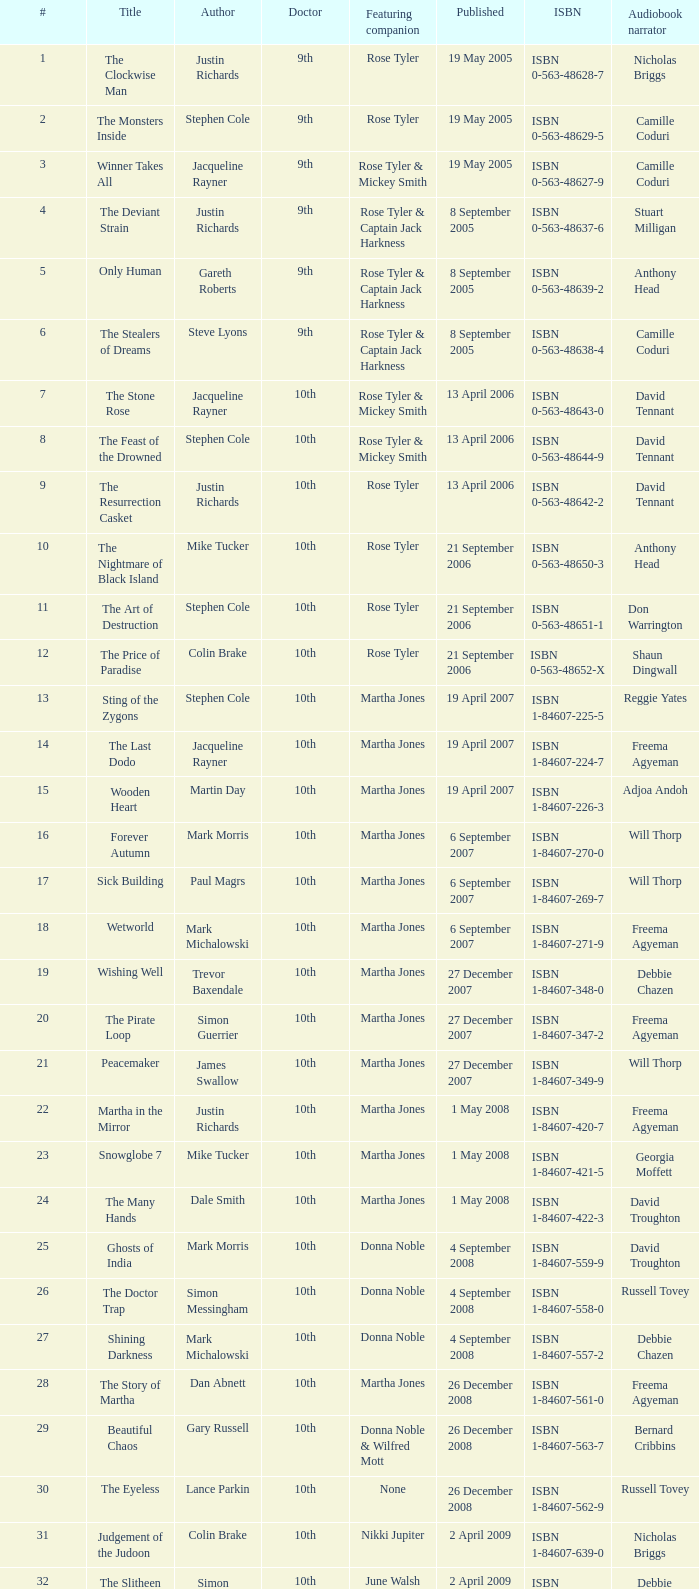What is the designation of book number 7? The Stone Rose. I'm looking to parse the entire table for insights. Could you assist me with that? {'header': ['#', 'Title', 'Author', 'Doctor', 'Featuring companion', 'Published', 'ISBN', 'Audiobook narrator'], 'rows': [['1', 'The Clockwise Man', 'Justin Richards', '9th', 'Rose Tyler', '19 May 2005', 'ISBN 0-563-48628-7', 'Nicholas Briggs'], ['2', 'The Monsters Inside', 'Stephen Cole', '9th', 'Rose Tyler', '19 May 2005', 'ISBN 0-563-48629-5', 'Camille Coduri'], ['3', 'Winner Takes All', 'Jacqueline Rayner', '9th', 'Rose Tyler & Mickey Smith', '19 May 2005', 'ISBN 0-563-48627-9', 'Camille Coduri'], ['4', 'The Deviant Strain', 'Justin Richards', '9th', 'Rose Tyler & Captain Jack Harkness', '8 September 2005', 'ISBN 0-563-48637-6', 'Stuart Milligan'], ['5', 'Only Human', 'Gareth Roberts', '9th', 'Rose Tyler & Captain Jack Harkness', '8 September 2005', 'ISBN 0-563-48639-2', 'Anthony Head'], ['6', 'The Stealers of Dreams', 'Steve Lyons', '9th', 'Rose Tyler & Captain Jack Harkness', '8 September 2005', 'ISBN 0-563-48638-4', 'Camille Coduri'], ['7', 'The Stone Rose', 'Jacqueline Rayner', '10th', 'Rose Tyler & Mickey Smith', '13 April 2006', 'ISBN 0-563-48643-0', 'David Tennant'], ['8', 'The Feast of the Drowned', 'Stephen Cole', '10th', 'Rose Tyler & Mickey Smith', '13 April 2006', 'ISBN 0-563-48644-9', 'David Tennant'], ['9', 'The Resurrection Casket', 'Justin Richards', '10th', 'Rose Tyler', '13 April 2006', 'ISBN 0-563-48642-2', 'David Tennant'], ['10', 'The Nightmare of Black Island', 'Mike Tucker', '10th', 'Rose Tyler', '21 September 2006', 'ISBN 0-563-48650-3', 'Anthony Head'], ['11', 'The Art of Destruction', 'Stephen Cole', '10th', 'Rose Tyler', '21 September 2006', 'ISBN 0-563-48651-1', 'Don Warrington'], ['12', 'The Price of Paradise', 'Colin Brake', '10th', 'Rose Tyler', '21 September 2006', 'ISBN 0-563-48652-X', 'Shaun Dingwall'], ['13', 'Sting of the Zygons', 'Stephen Cole', '10th', 'Martha Jones', '19 April 2007', 'ISBN 1-84607-225-5', 'Reggie Yates'], ['14', 'The Last Dodo', 'Jacqueline Rayner', '10th', 'Martha Jones', '19 April 2007', 'ISBN 1-84607-224-7', 'Freema Agyeman'], ['15', 'Wooden Heart', 'Martin Day', '10th', 'Martha Jones', '19 April 2007', 'ISBN 1-84607-226-3', 'Adjoa Andoh'], ['16', 'Forever Autumn', 'Mark Morris', '10th', 'Martha Jones', '6 September 2007', 'ISBN 1-84607-270-0', 'Will Thorp'], ['17', 'Sick Building', 'Paul Magrs', '10th', 'Martha Jones', '6 September 2007', 'ISBN 1-84607-269-7', 'Will Thorp'], ['18', 'Wetworld', 'Mark Michalowski', '10th', 'Martha Jones', '6 September 2007', 'ISBN 1-84607-271-9', 'Freema Agyeman'], ['19', 'Wishing Well', 'Trevor Baxendale', '10th', 'Martha Jones', '27 December 2007', 'ISBN 1-84607-348-0', 'Debbie Chazen'], ['20', 'The Pirate Loop', 'Simon Guerrier', '10th', 'Martha Jones', '27 December 2007', 'ISBN 1-84607-347-2', 'Freema Agyeman'], ['21', 'Peacemaker', 'James Swallow', '10th', 'Martha Jones', '27 December 2007', 'ISBN 1-84607-349-9', 'Will Thorp'], ['22', 'Martha in the Mirror', 'Justin Richards', '10th', 'Martha Jones', '1 May 2008', 'ISBN 1-84607-420-7', 'Freema Agyeman'], ['23', 'Snowglobe 7', 'Mike Tucker', '10th', 'Martha Jones', '1 May 2008', 'ISBN 1-84607-421-5', 'Georgia Moffett'], ['24', 'The Many Hands', 'Dale Smith', '10th', 'Martha Jones', '1 May 2008', 'ISBN 1-84607-422-3', 'David Troughton'], ['25', 'Ghosts of India', 'Mark Morris', '10th', 'Donna Noble', '4 September 2008', 'ISBN 1-84607-559-9', 'David Troughton'], ['26', 'The Doctor Trap', 'Simon Messingham', '10th', 'Donna Noble', '4 September 2008', 'ISBN 1-84607-558-0', 'Russell Tovey'], ['27', 'Shining Darkness', 'Mark Michalowski', '10th', 'Donna Noble', '4 September 2008', 'ISBN 1-84607-557-2', 'Debbie Chazen'], ['28', 'The Story of Martha', 'Dan Abnett', '10th', 'Martha Jones', '26 December 2008', 'ISBN 1-84607-561-0', 'Freema Agyeman'], ['29', 'Beautiful Chaos', 'Gary Russell', '10th', 'Donna Noble & Wilfred Mott', '26 December 2008', 'ISBN 1-84607-563-7', 'Bernard Cribbins'], ['30', 'The Eyeless', 'Lance Parkin', '10th', 'None', '26 December 2008', 'ISBN 1-84607-562-9', 'Russell Tovey'], ['31', 'Judgement of the Judoon', 'Colin Brake', '10th', 'Nikki Jupiter', '2 April 2009', 'ISBN 1-84607-639-0', 'Nicholas Briggs'], ['32', 'The Slitheen Excursion', 'Simon Guerrier', '10th', 'June Walsh', '2 April 2009', 'ISBN 1-84607-640-4', 'Debbie Chazen'], ['33', 'Prisoner of the Daleks', 'Trevor Baxendale', '10th', 'Jon Bowman', '2 April 2009', 'ISBN 1-84607-641-2', 'Nicholas Briggs'], ['34', 'The Taking of Chelsea 426', 'David Llewellyn', '10th', 'Jake & Vienna Carstairs', '17 September 2009', 'ISBN 1-84607-758-3', 'Christopher Ryan'], ['35', 'Autonomy', 'Daniel Blythe', '10th', 'Kate Maguire', '17 September 2009', 'ISBN 1-84607-759-1', 'Georgia Moffett'], ['36', 'The Krillitane Storm', 'Christopher Cooper', '10th', 'Emily Parr', '17 September 2009', 'ISBN 1-84607-761-3', 'Will Thorp'], ['37', 'Apollo 23', 'Justin Richards', '11th', 'Amy Pond', '22 April 2010', 'ISBN 1-84607-200-X', 'James Albrecht'], ['38', 'Night of the Humans', 'David Llewellyn', '11th', 'Amy Pond', '22 April 2010', 'ISBN 1-84607-969-1', 'Arthur Darvill'], ['39', 'The Forgotten Army', 'Brian Minchin', '11th', 'Amy Pond', '22 April 2010', 'ISBN 1-84607-987-X', 'Olivia Colman'], ['40', 'Nuclear Time', 'Oli Smith', '11th', 'Amy Pond & Rory Williams', '8 July 2010', 'ISBN 1-84607-989-6', 'Nicholas Briggs'], ['41', "The King's Dragon", 'Una McCormack', '11th', 'Amy Pond & Rory Williams', '8 July 2010', 'ISBN 1-84607-990-X', 'Nicholas Briggs'], ['42', 'The Glamour Chase', 'Gary Russell', '11th', 'Amy Pond & Rory Williams', '8 July 2010', 'ISBN 1-84607-988-8', 'Arthur Darvill'], ['S1', 'The Coming of the Terraphiles', 'Michael Moorcock', '11th', 'Amy Pond', '14 October 2010', 'ISBN 1-84607-983-7', 'Clive Mantle'], ['43', 'Dead of Winter', 'James Goss', '11th', 'Amy Pond & Rory Williams', '28 April 2011', 'ISBN 1-84990-238-0', 'Clare Corbett'], ['44', 'The Way Through the Woods', 'Una McCormack', '11th', 'Amy Pond & Rory Williams', '28 April 2011', 'ISBN 1-84990-237-2', 'Clare Corbett'], ['45', "Hunter's Moon", 'Paul Finch', '11th', 'Amy Pond & Rory Williams', '28 April 2011', 'ISBN 1-84990-236-4', 'Arthur Darvill'], ['46', 'Touched by an Angel', 'Jonathan Morris', '11th', 'Amy Pond & Rory Williams', '23 June 2011', 'ISBN 1-84990-234-8', 'Clare Corbett'], ['47', 'Paradox Lost', 'George Mann', '11th', 'Amy Pond & Rory Williams', '23 June 2011', 'ISBN 1-84990-235-6', 'Nicholas Briggs'], ['48', 'Borrowed Time', 'Naomi Alderman', '11th', 'Amy Pond & Rory Williams', '23 June 2011', 'ISBN 1-84990-233-X', 'Meera Syal'], ['S2', 'The Silent Stars Go By', 'Dan Abnett', '11th', 'Amy Pond & Rory Williams', '29 September 2011', 'ISBN 1-84990-243-7', 'Michael Maloney'], ['S3', 'Dark Horizons', 'J T Colgan', '11th', 'None', '7 July 2012', 'ISBN 1-84990-456-1', 'Neve McIntosh']]} 